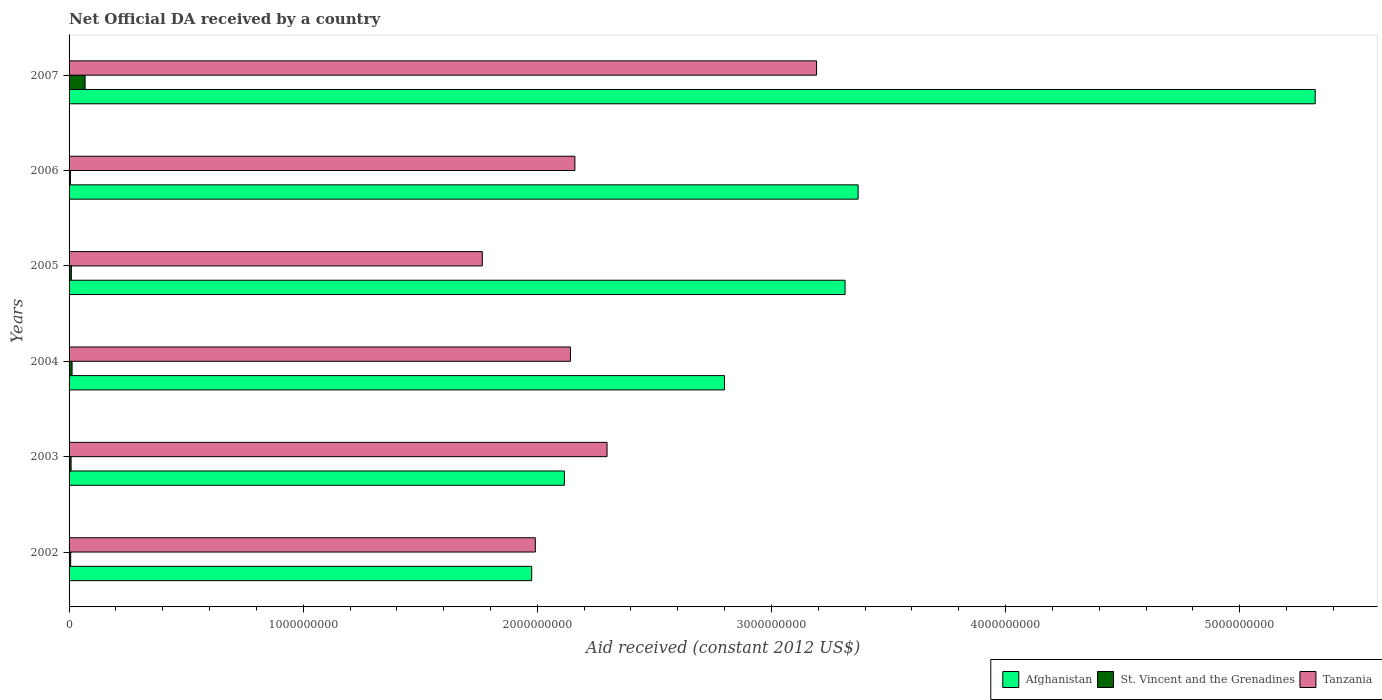Are the number of bars per tick equal to the number of legend labels?
Provide a short and direct response. Yes. Are the number of bars on each tick of the Y-axis equal?
Your response must be concise. Yes. What is the label of the 5th group of bars from the top?
Offer a very short reply. 2003. In how many cases, is the number of bars for a given year not equal to the number of legend labels?
Offer a terse response. 0. What is the net official development assistance aid received in Afghanistan in 2002?
Offer a terse response. 1.98e+09. Across all years, what is the maximum net official development assistance aid received in Afghanistan?
Offer a terse response. 5.32e+09. Across all years, what is the minimum net official development assistance aid received in Tanzania?
Offer a very short reply. 1.77e+09. What is the total net official development assistance aid received in Afghanistan in the graph?
Make the answer very short. 1.89e+1. What is the difference between the net official development assistance aid received in Afghanistan in 2004 and that in 2006?
Give a very brief answer. -5.71e+08. What is the difference between the net official development assistance aid received in Afghanistan in 2007 and the net official development assistance aid received in Tanzania in 2002?
Offer a terse response. 3.33e+09. What is the average net official development assistance aid received in Tanzania per year?
Provide a succinct answer. 2.26e+09. In the year 2002, what is the difference between the net official development assistance aid received in Tanzania and net official development assistance aid received in Afghanistan?
Ensure brevity in your answer.  1.55e+07. What is the ratio of the net official development assistance aid received in St. Vincent and the Grenadines in 2004 to that in 2005?
Make the answer very short. 1.32. Is the net official development assistance aid received in St. Vincent and the Grenadines in 2004 less than that in 2005?
Ensure brevity in your answer.  No. What is the difference between the highest and the second highest net official development assistance aid received in Afghanistan?
Your answer should be very brief. 1.95e+09. What is the difference between the highest and the lowest net official development assistance aid received in Tanzania?
Your answer should be very brief. 1.43e+09. In how many years, is the net official development assistance aid received in Tanzania greater than the average net official development assistance aid received in Tanzania taken over all years?
Give a very brief answer. 2. Is the sum of the net official development assistance aid received in Afghanistan in 2002 and 2005 greater than the maximum net official development assistance aid received in Tanzania across all years?
Make the answer very short. Yes. What does the 2nd bar from the top in 2006 represents?
Give a very brief answer. St. Vincent and the Grenadines. What does the 3rd bar from the bottom in 2004 represents?
Your answer should be very brief. Tanzania. How many bars are there?
Offer a very short reply. 18. Are all the bars in the graph horizontal?
Give a very brief answer. Yes. What is the difference between two consecutive major ticks on the X-axis?
Your response must be concise. 1.00e+09. Are the values on the major ticks of X-axis written in scientific E-notation?
Offer a terse response. No. Does the graph contain grids?
Your answer should be compact. No. How many legend labels are there?
Provide a succinct answer. 3. How are the legend labels stacked?
Give a very brief answer. Horizontal. What is the title of the graph?
Offer a terse response. Net Official DA received by a country. Does "Samoa" appear as one of the legend labels in the graph?
Your response must be concise. No. What is the label or title of the X-axis?
Give a very brief answer. Aid received (constant 2012 US$). What is the Aid received (constant 2012 US$) of Afghanistan in 2002?
Offer a terse response. 1.98e+09. What is the Aid received (constant 2012 US$) of St. Vincent and the Grenadines in 2002?
Offer a terse response. 6.87e+06. What is the Aid received (constant 2012 US$) in Tanzania in 2002?
Keep it short and to the point. 1.99e+09. What is the Aid received (constant 2012 US$) of Afghanistan in 2003?
Your response must be concise. 2.12e+09. What is the Aid received (constant 2012 US$) in St. Vincent and the Grenadines in 2003?
Your response must be concise. 8.61e+06. What is the Aid received (constant 2012 US$) in Tanzania in 2003?
Make the answer very short. 2.30e+09. What is the Aid received (constant 2012 US$) in Afghanistan in 2004?
Provide a succinct answer. 2.80e+09. What is the Aid received (constant 2012 US$) of St. Vincent and the Grenadines in 2004?
Your response must be concise. 1.29e+07. What is the Aid received (constant 2012 US$) of Tanzania in 2004?
Offer a terse response. 2.14e+09. What is the Aid received (constant 2012 US$) of Afghanistan in 2005?
Your answer should be compact. 3.31e+09. What is the Aid received (constant 2012 US$) in St. Vincent and the Grenadines in 2005?
Provide a succinct answer. 9.75e+06. What is the Aid received (constant 2012 US$) of Tanzania in 2005?
Your response must be concise. 1.77e+09. What is the Aid received (constant 2012 US$) in Afghanistan in 2006?
Keep it short and to the point. 3.37e+09. What is the Aid received (constant 2012 US$) of St. Vincent and the Grenadines in 2006?
Offer a very short reply. 5.68e+06. What is the Aid received (constant 2012 US$) in Tanzania in 2006?
Your answer should be compact. 2.16e+09. What is the Aid received (constant 2012 US$) in Afghanistan in 2007?
Your response must be concise. 5.32e+09. What is the Aid received (constant 2012 US$) in St. Vincent and the Grenadines in 2007?
Your answer should be very brief. 6.84e+07. What is the Aid received (constant 2012 US$) in Tanzania in 2007?
Your answer should be very brief. 3.19e+09. Across all years, what is the maximum Aid received (constant 2012 US$) in Afghanistan?
Make the answer very short. 5.32e+09. Across all years, what is the maximum Aid received (constant 2012 US$) in St. Vincent and the Grenadines?
Your response must be concise. 6.84e+07. Across all years, what is the maximum Aid received (constant 2012 US$) of Tanzania?
Make the answer very short. 3.19e+09. Across all years, what is the minimum Aid received (constant 2012 US$) of Afghanistan?
Your response must be concise. 1.98e+09. Across all years, what is the minimum Aid received (constant 2012 US$) of St. Vincent and the Grenadines?
Keep it short and to the point. 5.68e+06. Across all years, what is the minimum Aid received (constant 2012 US$) of Tanzania?
Keep it short and to the point. 1.77e+09. What is the total Aid received (constant 2012 US$) in Afghanistan in the graph?
Keep it short and to the point. 1.89e+1. What is the total Aid received (constant 2012 US$) in St. Vincent and the Grenadines in the graph?
Provide a short and direct response. 1.12e+08. What is the total Aid received (constant 2012 US$) in Tanzania in the graph?
Offer a very short reply. 1.35e+1. What is the difference between the Aid received (constant 2012 US$) in Afghanistan in 2002 and that in 2003?
Provide a short and direct response. -1.40e+08. What is the difference between the Aid received (constant 2012 US$) of St. Vincent and the Grenadines in 2002 and that in 2003?
Your answer should be compact. -1.74e+06. What is the difference between the Aid received (constant 2012 US$) of Tanzania in 2002 and that in 2003?
Give a very brief answer. -3.06e+08. What is the difference between the Aid received (constant 2012 US$) of Afghanistan in 2002 and that in 2004?
Give a very brief answer. -8.23e+08. What is the difference between the Aid received (constant 2012 US$) in St. Vincent and the Grenadines in 2002 and that in 2004?
Give a very brief answer. -5.99e+06. What is the difference between the Aid received (constant 2012 US$) in Tanzania in 2002 and that in 2004?
Provide a succinct answer. -1.50e+08. What is the difference between the Aid received (constant 2012 US$) of Afghanistan in 2002 and that in 2005?
Ensure brevity in your answer.  -1.34e+09. What is the difference between the Aid received (constant 2012 US$) in St. Vincent and the Grenadines in 2002 and that in 2005?
Keep it short and to the point. -2.88e+06. What is the difference between the Aid received (constant 2012 US$) in Tanzania in 2002 and that in 2005?
Keep it short and to the point. 2.26e+08. What is the difference between the Aid received (constant 2012 US$) in Afghanistan in 2002 and that in 2006?
Ensure brevity in your answer.  -1.39e+09. What is the difference between the Aid received (constant 2012 US$) in St. Vincent and the Grenadines in 2002 and that in 2006?
Give a very brief answer. 1.19e+06. What is the difference between the Aid received (constant 2012 US$) of Tanzania in 2002 and that in 2006?
Keep it short and to the point. -1.69e+08. What is the difference between the Aid received (constant 2012 US$) in Afghanistan in 2002 and that in 2007?
Ensure brevity in your answer.  -3.35e+09. What is the difference between the Aid received (constant 2012 US$) in St. Vincent and the Grenadines in 2002 and that in 2007?
Offer a very short reply. -6.16e+07. What is the difference between the Aid received (constant 2012 US$) in Tanzania in 2002 and that in 2007?
Keep it short and to the point. -1.20e+09. What is the difference between the Aid received (constant 2012 US$) in Afghanistan in 2003 and that in 2004?
Your answer should be compact. -6.84e+08. What is the difference between the Aid received (constant 2012 US$) in St. Vincent and the Grenadines in 2003 and that in 2004?
Make the answer very short. -4.25e+06. What is the difference between the Aid received (constant 2012 US$) of Tanzania in 2003 and that in 2004?
Ensure brevity in your answer.  1.56e+08. What is the difference between the Aid received (constant 2012 US$) of Afghanistan in 2003 and that in 2005?
Offer a terse response. -1.20e+09. What is the difference between the Aid received (constant 2012 US$) of St. Vincent and the Grenadines in 2003 and that in 2005?
Provide a succinct answer. -1.14e+06. What is the difference between the Aid received (constant 2012 US$) of Tanzania in 2003 and that in 2005?
Give a very brief answer. 5.33e+08. What is the difference between the Aid received (constant 2012 US$) in Afghanistan in 2003 and that in 2006?
Ensure brevity in your answer.  -1.25e+09. What is the difference between the Aid received (constant 2012 US$) of St. Vincent and the Grenadines in 2003 and that in 2006?
Make the answer very short. 2.93e+06. What is the difference between the Aid received (constant 2012 US$) in Tanzania in 2003 and that in 2006?
Provide a succinct answer. 1.37e+08. What is the difference between the Aid received (constant 2012 US$) in Afghanistan in 2003 and that in 2007?
Offer a very short reply. -3.21e+09. What is the difference between the Aid received (constant 2012 US$) in St. Vincent and the Grenadines in 2003 and that in 2007?
Give a very brief answer. -5.98e+07. What is the difference between the Aid received (constant 2012 US$) of Tanzania in 2003 and that in 2007?
Your response must be concise. -8.95e+08. What is the difference between the Aid received (constant 2012 US$) in Afghanistan in 2004 and that in 2005?
Ensure brevity in your answer.  -5.15e+08. What is the difference between the Aid received (constant 2012 US$) of St. Vincent and the Grenadines in 2004 and that in 2005?
Your response must be concise. 3.11e+06. What is the difference between the Aid received (constant 2012 US$) in Tanzania in 2004 and that in 2005?
Offer a terse response. 3.77e+08. What is the difference between the Aid received (constant 2012 US$) in Afghanistan in 2004 and that in 2006?
Offer a very short reply. -5.71e+08. What is the difference between the Aid received (constant 2012 US$) of St. Vincent and the Grenadines in 2004 and that in 2006?
Provide a succinct answer. 7.18e+06. What is the difference between the Aid received (constant 2012 US$) in Tanzania in 2004 and that in 2006?
Keep it short and to the point. -1.90e+07. What is the difference between the Aid received (constant 2012 US$) in Afghanistan in 2004 and that in 2007?
Give a very brief answer. -2.52e+09. What is the difference between the Aid received (constant 2012 US$) in St. Vincent and the Grenadines in 2004 and that in 2007?
Provide a succinct answer. -5.56e+07. What is the difference between the Aid received (constant 2012 US$) in Tanzania in 2004 and that in 2007?
Provide a short and direct response. -1.05e+09. What is the difference between the Aid received (constant 2012 US$) in Afghanistan in 2005 and that in 2006?
Your answer should be compact. -5.58e+07. What is the difference between the Aid received (constant 2012 US$) of St. Vincent and the Grenadines in 2005 and that in 2006?
Keep it short and to the point. 4.07e+06. What is the difference between the Aid received (constant 2012 US$) in Tanzania in 2005 and that in 2006?
Keep it short and to the point. -3.96e+08. What is the difference between the Aid received (constant 2012 US$) of Afghanistan in 2005 and that in 2007?
Make the answer very short. -2.01e+09. What is the difference between the Aid received (constant 2012 US$) of St. Vincent and the Grenadines in 2005 and that in 2007?
Your answer should be very brief. -5.87e+07. What is the difference between the Aid received (constant 2012 US$) in Tanzania in 2005 and that in 2007?
Give a very brief answer. -1.43e+09. What is the difference between the Aid received (constant 2012 US$) in Afghanistan in 2006 and that in 2007?
Offer a terse response. -1.95e+09. What is the difference between the Aid received (constant 2012 US$) in St. Vincent and the Grenadines in 2006 and that in 2007?
Offer a very short reply. -6.27e+07. What is the difference between the Aid received (constant 2012 US$) of Tanzania in 2006 and that in 2007?
Offer a very short reply. -1.03e+09. What is the difference between the Aid received (constant 2012 US$) of Afghanistan in 2002 and the Aid received (constant 2012 US$) of St. Vincent and the Grenadines in 2003?
Offer a very short reply. 1.97e+09. What is the difference between the Aid received (constant 2012 US$) in Afghanistan in 2002 and the Aid received (constant 2012 US$) in Tanzania in 2003?
Offer a very short reply. -3.22e+08. What is the difference between the Aid received (constant 2012 US$) of St. Vincent and the Grenadines in 2002 and the Aid received (constant 2012 US$) of Tanzania in 2003?
Your answer should be very brief. -2.29e+09. What is the difference between the Aid received (constant 2012 US$) in Afghanistan in 2002 and the Aid received (constant 2012 US$) in St. Vincent and the Grenadines in 2004?
Your answer should be very brief. 1.96e+09. What is the difference between the Aid received (constant 2012 US$) of Afghanistan in 2002 and the Aid received (constant 2012 US$) of Tanzania in 2004?
Keep it short and to the point. -1.66e+08. What is the difference between the Aid received (constant 2012 US$) in St. Vincent and the Grenadines in 2002 and the Aid received (constant 2012 US$) in Tanzania in 2004?
Offer a very short reply. -2.13e+09. What is the difference between the Aid received (constant 2012 US$) in Afghanistan in 2002 and the Aid received (constant 2012 US$) in St. Vincent and the Grenadines in 2005?
Make the answer very short. 1.97e+09. What is the difference between the Aid received (constant 2012 US$) in Afghanistan in 2002 and the Aid received (constant 2012 US$) in Tanzania in 2005?
Offer a very short reply. 2.11e+08. What is the difference between the Aid received (constant 2012 US$) of St. Vincent and the Grenadines in 2002 and the Aid received (constant 2012 US$) of Tanzania in 2005?
Ensure brevity in your answer.  -1.76e+09. What is the difference between the Aid received (constant 2012 US$) in Afghanistan in 2002 and the Aid received (constant 2012 US$) in St. Vincent and the Grenadines in 2006?
Provide a succinct answer. 1.97e+09. What is the difference between the Aid received (constant 2012 US$) in Afghanistan in 2002 and the Aid received (constant 2012 US$) in Tanzania in 2006?
Offer a terse response. -1.85e+08. What is the difference between the Aid received (constant 2012 US$) of St. Vincent and the Grenadines in 2002 and the Aid received (constant 2012 US$) of Tanzania in 2006?
Your response must be concise. -2.15e+09. What is the difference between the Aid received (constant 2012 US$) in Afghanistan in 2002 and the Aid received (constant 2012 US$) in St. Vincent and the Grenadines in 2007?
Give a very brief answer. 1.91e+09. What is the difference between the Aid received (constant 2012 US$) in Afghanistan in 2002 and the Aid received (constant 2012 US$) in Tanzania in 2007?
Provide a short and direct response. -1.22e+09. What is the difference between the Aid received (constant 2012 US$) of St. Vincent and the Grenadines in 2002 and the Aid received (constant 2012 US$) of Tanzania in 2007?
Make the answer very short. -3.19e+09. What is the difference between the Aid received (constant 2012 US$) in Afghanistan in 2003 and the Aid received (constant 2012 US$) in St. Vincent and the Grenadines in 2004?
Your answer should be compact. 2.10e+09. What is the difference between the Aid received (constant 2012 US$) of Afghanistan in 2003 and the Aid received (constant 2012 US$) of Tanzania in 2004?
Offer a terse response. -2.58e+07. What is the difference between the Aid received (constant 2012 US$) in St. Vincent and the Grenadines in 2003 and the Aid received (constant 2012 US$) in Tanzania in 2004?
Give a very brief answer. -2.13e+09. What is the difference between the Aid received (constant 2012 US$) of Afghanistan in 2003 and the Aid received (constant 2012 US$) of St. Vincent and the Grenadines in 2005?
Make the answer very short. 2.11e+09. What is the difference between the Aid received (constant 2012 US$) of Afghanistan in 2003 and the Aid received (constant 2012 US$) of Tanzania in 2005?
Your response must be concise. 3.51e+08. What is the difference between the Aid received (constant 2012 US$) in St. Vincent and the Grenadines in 2003 and the Aid received (constant 2012 US$) in Tanzania in 2005?
Keep it short and to the point. -1.76e+09. What is the difference between the Aid received (constant 2012 US$) of Afghanistan in 2003 and the Aid received (constant 2012 US$) of St. Vincent and the Grenadines in 2006?
Ensure brevity in your answer.  2.11e+09. What is the difference between the Aid received (constant 2012 US$) of Afghanistan in 2003 and the Aid received (constant 2012 US$) of Tanzania in 2006?
Keep it short and to the point. -4.48e+07. What is the difference between the Aid received (constant 2012 US$) in St. Vincent and the Grenadines in 2003 and the Aid received (constant 2012 US$) in Tanzania in 2006?
Ensure brevity in your answer.  -2.15e+09. What is the difference between the Aid received (constant 2012 US$) of Afghanistan in 2003 and the Aid received (constant 2012 US$) of St. Vincent and the Grenadines in 2007?
Give a very brief answer. 2.05e+09. What is the difference between the Aid received (constant 2012 US$) of Afghanistan in 2003 and the Aid received (constant 2012 US$) of Tanzania in 2007?
Give a very brief answer. -1.08e+09. What is the difference between the Aid received (constant 2012 US$) in St. Vincent and the Grenadines in 2003 and the Aid received (constant 2012 US$) in Tanzania in 2007?
Give a very brief answer. -3.18e+09. What is the difference between the Aid received (constant 2012 US$) of Afghanistan in 2004 and the Aid received (constant 2012 US$) of St. Vincent and the Grenadines in 2005?
Your answer should be very brief. 2.79e+09. What is the difference between the Aid received (constant 2012 US$) of Afghanistan in 2004 and the Aid received (constant 2012 US$) of Tanzania in 2005?
Your answer should be very brief. 1.03e+09. What is the difference between the Aid received (constant 2012 US$) in St. Vincent and the Grenadines in 2004 and the Aid received (constant 2012 US$) in Tanzania in 2005?
Ensure brevity in your answer.  -1.75e+09. What is the difference between the Aid received (constant 2012 US$) of Afghanistan in 2004 and the Aid received (constant 2012 US$) of St. Vincent and the Grenadines in 2006?
Ensure brevity in your answer.  2.79e+09. What is the difference between the Aid received (constant 2012 US$) of Afghanistan in 2004 and the Aid received (constant 2012 US$) of Tanzania in 2006?
Give a very brief answer. 6.39e+08. What is the difference between the Aid received (constant 2012 US$) of St. Vincent and the Grenadines in 2004 and the Aid received (constant 2012 US$) of Tanzania in 2006?
Make the answer very short. -2.15e+09. What is the difference between the Aid received (constant 2012 US$) in Afghanistan in 2004 and the Aid received (constant 2012 US$) in St. Vincent and the Grenadines in 2007?
Your answer should be very brief. 2.73e+09. What is the difference between the Aid received (constant 2012 US$) in Afghanistan in 2004 and the Aid received (constant 2012 US$) in Tanzania in 2007?
Make the answer very short. -3.93e+08. What is the difference between the Aid received (constant 2012 US$) in St. Vincent and the Grenadines in 2004 and the Aid received (constant 2012 US$) in Tanzania in 2007?
Offer a terse response. -3.18e+09. What is the difference between the Aid received (constant 2012 US$) in Afghanistan in 2005 and the Aid received (constant 2012 US$) in St. Vincent and the Grenadines in 2006?
Your response must be concise. 3.31e+09. What is the difference between the Aid received (constant 2012 US$) in Afghanistan in 2005 and the Aid received (constant 2012 US$) in Tanzania in 2006?
Your answer should be very brief. 1.15e+09. What is the difference between the Aid received (constant 2012 US$) of St. Vincent and the Grenadines in 2005 and the Aid received (constant 2012 US$) of Tanzania in 2006?
Provide a short and direct response. -2.15e+09. What is the difference between the Aid received (constant 2012 US$) in Afghanistan in 2005 and the Aid received (constant 2012 US$) in St. Vincent and the Grenadines in 2007?
Make the answer very short. 3.25e+09. What is the difference between the Aid received (constant 2012 US$) of Afghanistan in 2005 and the Aid received (constant 2012 US$) of Tanzania in 2007?
Your answer should be very brief. 1.22e+08. What is the difference between the Aid received (constant 2012 US$) of St. Vincent and the Grenadines in 2005 and the Aid received (constant 2012 US$) of Tanzania in 2007?
Keep it short and to the point. -3.18e+09. What is the difference between the Aid received (constant 2012 US$) in Afghanistan in 2006 and the Aid received (constant 2012 US$) in St. Vincent and the Grenadines in 2007?
Your answer should be compact. 3.30e+09. What is the difference between the Aid received (constant 2012 US$) in Afghanistan in 2006 and the Aid received (constant 2012 US$) in Tanzania in 2007?
Your response must be concise. 1.77e+08. What is the difference between the Aid received (constant 2012 US$) in St. Vincent and the Grenadines in 2006 and the Aid received (constant 2012 US$) in Tanzania in 2007?
Provide a succinct answer. -3.19e+09. What is the average Aid received (constant 2012 US$) in Afghanistan per year?
Your answer should be compact. 3.15e+09. What is the average Aid received (constant 2012 US$) of St. Vincent and the Grenadines per year?
Ensure brevity in your answer.  1.87e+07. What is the average Aid received (constant 2012 US$) in Tanzania per year?
Your response must be concise. 2.26e+09. In the year 2002, what is the difference between the Aid received (constant 2012 US$) in Afghanistan and Aid received (constant 2012 US$) in St. Vincent and the Grenadines?
Your answer should be very brief. 1.97e+09. In the year 2002, what is the difference between the Aid received (constant 2012 US$) in Afghanistan and Aid received (constant 2012 US$) in Tanzania?
Offer a terse response. -1.55e+07. In the year 2002, what is the difference between the Aid received (constant 2012 US$) in St. Vincent and the Grenadines and Aid received (constant 2012 US$) in Tanzania?
Provide a succinct answer. -1.98e+09. In the year 2003, what is the difference between the Aid received (constant 2012 US$) of Afghanistan and Aid received (constant 2012 US$) of St. Vincent and the Grenadines?
Keep it short and to the point. 2.11e+09. In the year 2003, what is the difference between the Aid received (constant 2012 US$) of Afghanistan and Aid received (constant 2012 US$) of Tanzania?
Give a very brief answer. -1.82e+08. In the year 2003, what is the difference between the Aid received (constant 2012 US$) of St. Vincent and the Grenadines and Aid received (constant 2012 US$) of Tanzania?
Your answer should be very brief. -2.29e+09. In the year 2004, what is the difference between the Aid received (constant 2012 US$) in Afghanistan and Aid received (constant 2012 US$) in St. Vincent and the Grenadines?
Keep it short and to the point. 2.79e+09. In the year 2004, what is the difference between the Aid received (constant 2012 US$) of Afghanistan and Aid received (constant 2012 US$) of Tanzania?
Make the answer very short. 6.58e+08. In the year 2004, what is the difference between the Aid received (constant 2012 US$) in St. Vincent and the Grenadines and Aid received (constant 2012 US$) in Tanzania?
Your answer should be very brief. -2.13e+09. In the year 2005, what is the difference between the Aid received (constant 2012 US$) of Afghanistan and Aid received (constant 2012 US$) of St. Vincent and the Grenadines?
Offer a terse response. 3.30e+09. In the year 2005, what is the difference between the Aid received (constant 2012 US$) in Afghanistan and Aid received (constant 2012 US$) in Tanzania?
Ensure brevity in your answer.  1.55e+09. In the year 2005, what is the difference between the Aid received (constant 2012 US$) of St. Vincent and the Grenadines and Aid received (constant 2012 US$) of Tanzania?
Your answer should be compact. -1.76e+09. In the year 2006, what is the difference between the Aid received (constant 2012 US$) in Afghanistan and Aid received (constant 2012 US$) in St. Vincent and the Grenadines?
Give a very brief answer. 3.36e+09. In the year 2006, what is the difference between the Aid received (constant 2012 US$) of Afghanistan and Aid received (constant 2012 US$) of Tanzania?
Ensure brevity in your answer.  1.21e+09. In the year 2006, what is the difference between the Aid received (constant 2012 US$) in St. Vincent and the Grenadines and Aid received (constant 2012 US$) in Tanzania?
Give a very brief answer. -2.15e+09. In the year 2007, what is the difference between the Aid received (constant 2012 US$) in Afghanistan and Aid received (constant 2012 US$) in St. Vincent and the Grenadines?
Keep it short and to the point. 5.25e+09. In the year 2007, what is the difference between the Aid received (constant 2012 US$) in Afghanistan and Aid received (constant 2012 US$) in Tanzania?
Ensure brevity in your answer.  2.13e+09. In the year 2007, what is the difference between the Aid received (constant 2012 US$) of St. Vincent and the Grenadines and Aid received (constant 2012 US$) of Tanzania?
Offer a terse response. -3.12e+09. What is the ratio of the Aid received (constant 2012 US$) in Afghanistan in 2002 to that in 2003?
Ensure brevity in your answer.  0.93. What is the ratio of the Aid received (constant 2012 US$) in St. Vincent and the Grenadines in 2002 to that in 2003?
Provide a succinct answer. 0.8. What is the ratio of the Aid received (constant 2012 US$) of Tanzania in 2002 to that in 2003?
Offer a very short reply. 0.87. What is the ratio of the Aid received (constant 2012 US$) of Afghanistan in 2002 to that in 2004?
Your answer should be compact. 0.71. What is the ratio of the Aid received (constant 2012 US$) of St. Vincent and the Grenadines in 2002 to that in 2004?
Offer a very short reply. 0.53. What is the ratio of the Aid received (constant 2012 US$) of Tanzania in 2002 to that in 2004?
Your answer should be very brief. 0.93. What is the ratio of the Aid received (constant 2012 US$) of Afghanistan in 2002 to that in 2005?
Ensure brevity in your answer.  0.6. What is the ratio of the Aid received (constant 2012 US$) of St. Vincent and the Grenadines in 2002 to that in 2005?
Keep it short and to the point. 0.7. What is the ratio of the Aid received (constant 2012 US$) of Tanzania in 2002 to that in 2005?
Keep it short and to the point. 1.13. What is the ratio of the Aid received (constant 2012 US$) of Afghanistan in 2002 to that in 2006?
Ensure brevity in your answer.  0.59. What is the ratio of the Aid received (constant 2012 US$) of St. Vincent and the Grenadines in 2002 to that in 2006?
Your answer should be very brief. 1.21. What is the ratio of the Aid received (constant 2012 US$) of Tanzania in 2002 to that in 2006?
Keep it short and to the point. 0.92. What is the ratio of the Aid received (constant 2012 US$) of Afghanistan in 2002 to that in 2007?
Your answer should be compact. 0.37. What is the ratio of the Aid received (constant 2012 US$) of St. Vincent and the Grenadines in 2002 to that in 2007?
Give a very brief answer. 0.1. What is the ratio of the Aid received (constant 2012 US$) in Tanzania in 2002 to that in 2007?
Your answer should be very brief. 0.62. What is the ratio of the Aid received (constant 2012 US$) of Afghanistan in 2003 to that in 2004?
Provide a short and direct response. 0.76. What is the ratio of the Aid received (constant 2012 US$) in St. Vincent and the Grenadines in 2003 to that in 2004?
Ensure brevity in your answer.  0.67. What is the ratio of the Aid received (constant 2012 US$) in Tanzania in 2003 to that in 2004?
Make the answer very short. 1.07. What is the ratio of the Aid received (constant 2012 US$) in Afghanistan in 2003 to that in 2005?
Keep it short and to the point. 0.64. What is the ratio of the Aid received (constant 2012 US$) of St. Vincent and the Grenadines in 2003 to that in 2005?
Keep it short and to the point. 0.88. What is the ratio of the Aid received (constant 2012 US$) in Tanzania in 2003 to that in 2005?
Your answer should be compact. 1.3. What is the ratio of the Aid received (constant 2012 US$) in Afghanistan in 2003 to that in 2006?
Ensure brevity in your answer.  0.63. What is the ratio of the Aid received (constant 2012 US$) in St. Vincent and the Grenadines in 2003 to that in 2006?
Ensure brevity in your answer.  1.52. What is the ratio of the Aid received (constant 2012 US$) in Tanzania in 2003 to that in 2006?
Your response must be concise. 1.06. What is the ratio of the Aid received (constant 2012 US$) of Afghanistan in 2003 to that in 2007?
Offer a very short reply. 0.4. What is the ratio of the Aid received (constant 2012 US$) of St. Vincent and the Grenadines in 2003 to that in 2007?
Your answer should be compact. 0.13. What is the ratio of the Aid received (constant 2012 US$) in Tanzania in 2003 to that in 2007?
Offer a very short reply. 0.72. What is the ratio of the Aid received (constant 2012 US$) of Afghanistan in 2004 to that in 2005?
Give a very brief answer. 0.84. What is the ratio of the Aid received (constant 2012 US$) of St. Vincent and the Grenadines in 2004 to that in 2005?
Offer a terse response. 1.32. What is the ratio of the Aid received (constant 2012 US$) in Tanzania in 2004 to that in 2005?
Make the answer very short. 1.21. What is the ratio of the Aid received (constant 2012 US$) in Afghanistan in 2004 to that in 2006?
Offer a very short reply. 0.83. What is the ratio of the Aid received (constant 2012 US$) in St. Vincent and the Grenadines in 2004 to that in 2006?
Give a very brief answer. 2.26. What is the ratio of the Aid received (constant 2012 US$) of Afghanistan in 2004 to that in 2007?
Ensure brevity in your answer.  0.53. What is the ratio of the Aid received (constant 2012 US$) in St. Vincent and the Grenadines in 2004 to that in 2007?
Your answer should be very brief. 0.19. What is the ratio of the Aid received (constant 2012 US$) in Tanzania in 2004 to that in 2007?
Ensure brevity in your answer.  0.67. What is the ratio of the Aid received (constant 2012 US$) in Afghanistan in 2005 to that in 2006?
Make the answer very short. 0.98. What is the ratio of the Aid received (constant 2012 US$) in St. Vincent and the Grenadines in 2005 to that in 2006?
Your answer should be compact. 1.72. What is the ratio of the Aid received (constant 2012 US$) of Tanzania in 2005 to that in 2006?
Offer a very short reply. 0.82. What is the ratio of the Aid received (constant 2012 US$) of Afghanistan in 2005 to that in 2007?
Your response must be concise. 0.62. What is the ratio of the Aid received (constant 2012 US$) of St. Vincent and the Grenadines in 2005 to that in 2007?
Provide a short and direct response. 0.14. What is the ratio of the Aid received (constant 2012 US$) of Tanzania in 2005 to that in 2007?
Your answer should be very brief. 0.55. What is the ratio of the Aid received (constant 2012 US$) of Afghanistan in 2006 to that in 2007?
Make the answer very short. 0.63. What is the ratio of the Aid received (constant 2012 US$) in St. Vincent and the Grenadines in 2006 to that in 2007?
Give a very brief answer. 0.08. What is the ratio of the Aid received (constant 2012 US$) in Tanzania in 2006 to that in 2007?
Provide a succinct answer. 0.68. What is the difference between the highest and the second highest Aid received (constant 2012 US$) of Afghanistan?
Give a very brief answer. 1.95e+09. What is the difference between the highest and the second highest Aid received (constant 2012 US$) of St. Vincent and the Grenadines?
Make the answer very short. 5.56e+07. What is the difference between the highest and the second highest Aid received (constant 2012 US$) of Tanzania?
Your response must be concise. 8.95e+08. What is the difference between the highest and the lowest Aid received (constant 2012 US$) in Afghanistan?
Make the answer very short. 3.35e+09. What is the difference between the highest and the lowest Aid received (constant 2012 US$) of St. Vincent and the Grenadines?
Keep it short and to the point. 6.27e+07. What is the difference between the highest and the lowest Aid received (constant 2012 US$) in Tanzania?
Offer a terse response. 1.43e+09. 